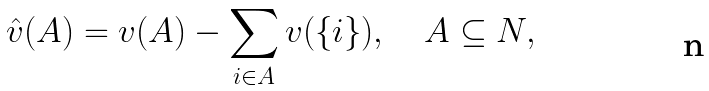<formula> <loc_0><loc_0><loc_500><loc_500>\hat { v } ( A ) = v ( A ) - \sum _ { i \in A } v ( \{ i \} ) , \quad A \subseteq N ,</formula> 